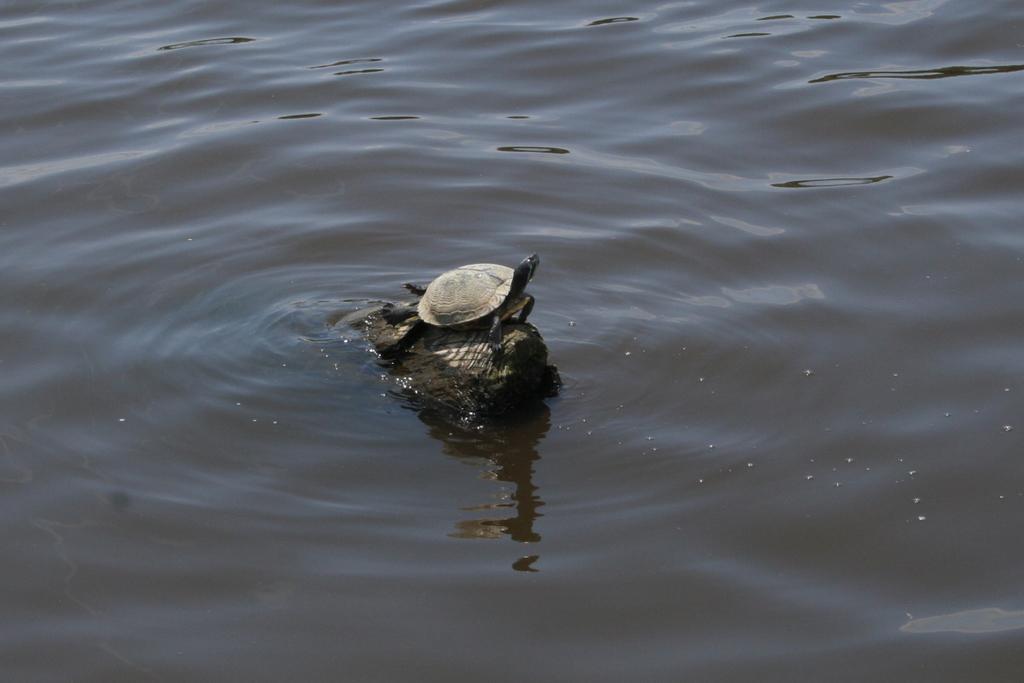Describe this image in one or two sentences. This picture shows about the small turtle in the water pound. 